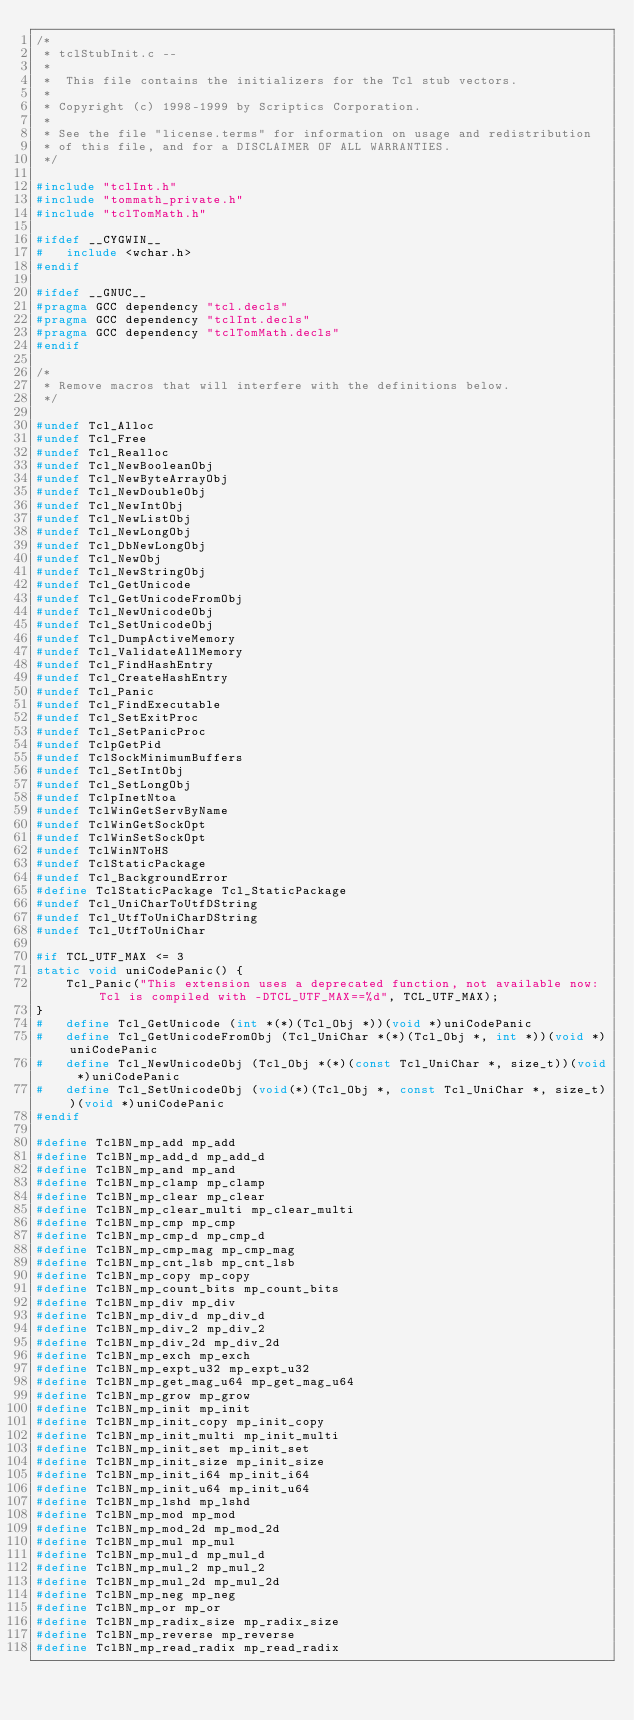<code> <loc_0><loc_0><loc_500><loc_500><_C_>/*
 * tclStubInit.c --
 *
 *	This file contains the initializers for the Tcl stub vectors.
 *
 * Copyright (c) 1998-1999 by Scriptics Corporation.
 *
 * See the file "license.terms" for information on usage and redistribution
 * of this file, and for a DISCLAIMER OF ALL WARRANTIES.
 */

#include "tclInt.h"
#include "tommath_private.h"
#include "tclTomMath.h"

#ifdef __CYGWIN__
#   include <wchar.h>
#endif

#ifdef __GNUC__
#pragma GCC dependency "tcl.decls"
#pragma GCC dependency "tclInt.decls"
#pragma GCC dependency "tclTomMath.decls"
#endif

/*
 * Remove macros that will interfere with the definitions below.
 */

#undef Tcl_Alloc
#undef Tcl_Free
#undef Tcl_Realloc
#undef Tcl_NewBooleanObj
#undef Tcl_NewByteArrayObj
#undef Tcl_NewDoubleObj
#undef Tcl_NewIntObj
#undef Tcl_NewListObj
#undef Tcl_NewLongObj
#undef Tcl_DbNewLongObj
#undef Tcl_NewObj
#undef Tcl_NewStringObj
#undef Tcl_GetUnicode
#undef Tcl_GetUnicodeFromObj
#undef Tcl_NewUnicodeObj
#undef Tcl_SetUnicodeObj
#undef Tcl_DumpActiveMemory
#undef Tcl_ValidateAllMemory
#undef Tcl_FindHashEntry
#undef Tcl_CreateHashEntry
#undef Tcl_Panic
#undef Tcl_FindExecutable
#undef Tcl_SetExitProc
#undef Tcl_SetPanicProc
#undef TclpGetPid
#undef TclSockMinimumBuffers
#undef Tcl_SetIntObj
#undef Tcl_SetLongObj
#undef TclpInetNtoa
#undef TclWinGetServByName
#undef TclWinGetSockOpt
#undef TclWinSetSockOpt
#undef TclWinNToHS
#undef TclStaticPackage
#undef Tcl_BackgroundError
#define TclStaticPackage Tcl_StaticPackage
#undef Tcl_UniCharToUtfDString
#undef Tcl_UtfToUniCharDString
#undef Tcl_UtfToUniChar

#if TCL_UTF_MAX <= 3
static void uniCodePanic() {
    Tcl_Panic("This extension uses a deprecated function, not available now: Tcl is compiled with -DTCL_UTF_MAX==%d", TCL_UTF_MAX);
}
#   define Tcl_GetUnicode (int *(*)(Tcl_Obj *))(void *)uniCodePanic
#   define Tcl_GetUnicodeFromObj (Tcl_UniChar *(*)(Tcl_Obj *, int *))(void *)uniCodePanic
#   define Tcl_NewUnicodeObj (Tcl_Obj *(*)(const Tcl_UniChar *, size_t))(void *)uniCodePanic
#   define Tcl_SetUnicodeObj (void(*)(Tcl_Obj *, const Tcl_UniChar *, size_t))(void *)uniCodePanic
#endif

#define TclBN_mp_add mp_add
#define TclBN_mp_add_d mp_add_d
#define TclBN_mp_and mp_and
#define TclBN_mp_clamp mp_clamp
#define TclBN_mp_clear mp_clear
#define TclBN_mp_clear_multi mp_clear_multi
#define TclBN_mp_cmp mp_cmp
#define TclBN_mp_cmp_d mp_cmp_d
#define TclBN_mp_cmp_mag mp_cmp_mag
#define TclBN_mp_cnt_lsb mp_cnt_lsb
#define TclBN_mp_copy mp_copy
#define TclBN_mp_count_bits mp_count_bits
#define TclBN_mp_div mp_div
#define TclBN_mp_div_d mp_div_d
#define TclBN_mp_div_2 mp_div_2
#define TclBN_mp_div_2d mp_div_2d
#define TclBN_mp_exch mp_exch
#define TclBN_mp_expt_u32 mp_expt_u32
#define TclBN_mp_get_mag_u64 mp_get_mag_u64
#define TclBN_mp_grow mp_grow
#define TclBN_mp_init mp_init
#define TclBN_mp_init_copy mp_init_copy
#define TclBN_mp_init_multi mp_init_multi
#define TclBN_mp_init_set mp_init_set
#define TclBN_mp_init_size mp_init_size
#define TclBN_mp_init_i64 mp_init_i64
#define TclBN_mp_init_u64 mp_init_u64
#define TclBN_mp_lshd mp_lshd
#define TclBN_mp_mod mp_mod
#define TclBN_mp_mod_2d mp_mod_2d
#define TclBN_mp_mul mp_mul
#define TclBN_mp_mul_d mp_mul_d
#define TclBN_mp_mul_2 mp_mul_2
#define TclBN_mp_mul_2d mp_mul_2d
#define TclBN_mp_neg mp_neg
#define TclBN_mp_or mp_or
#define TclBN_mp_radix_size mp_radix_size
#define TclBN_mp_reverse mp_reverse
#define TclBN_mp_read_radix mp_read_radix</code> 